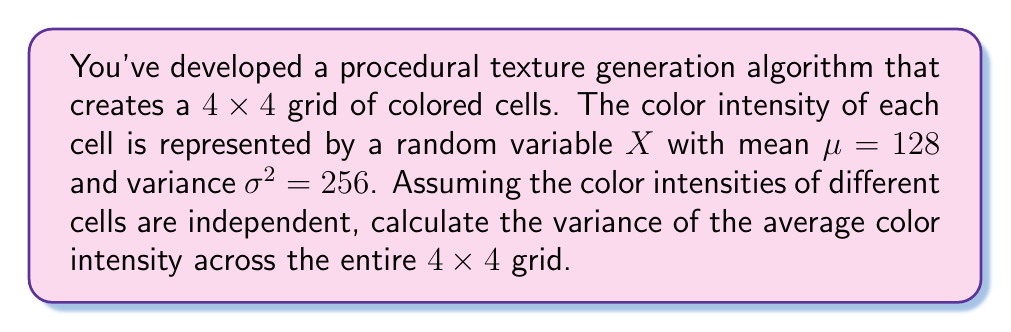Teach me how to tackle this problem. Let's approach this step-by-step:

1) First, we need to understand what we're calculating. We want the variance of the average color intensity across the entire grid.

2) Let's denote the average color intensity as $\bar{X}$. For a 4x4 grid, this would be:

   $$\bar{X} = \frac{1}{16}\sum_{i=1}^{16} X_i$$

   where $X_i$ represents the color intensity of the $i$-th cell.

3) We're given that each $X_i$ has a mean $\mu = 128$ and variance $\sigma^2 = 256$.

4) To find $Var(\bar{X})$, we can use the following property of variance:

   For independent random variables, the variance of their sum is the sum of their variances.

5) Additionally, when a random variable is multiplied by a constant $c$, its variance is multiplied by $c^2$.

6) Applying these properties:

   $$Var(\bar{X}) = Var(\frac{1}{16}\sum_{i=1}^{16} X_i) = (\frac{1}{16})^2 \sum_{i=1}^{16} Var(X_i)$$

7) Since all $X_i$ have the same variance of 256:

   $$Var(\bar{X}) = (\frac{1}{16})^2 \cdot 16 \cdot 256 = \frac{256}{16} = 16$$

Thus, the variance of the average color intensity across the entire 4x4 grid is 16.
Answer: $Var(\bar{X}) = 16$ 